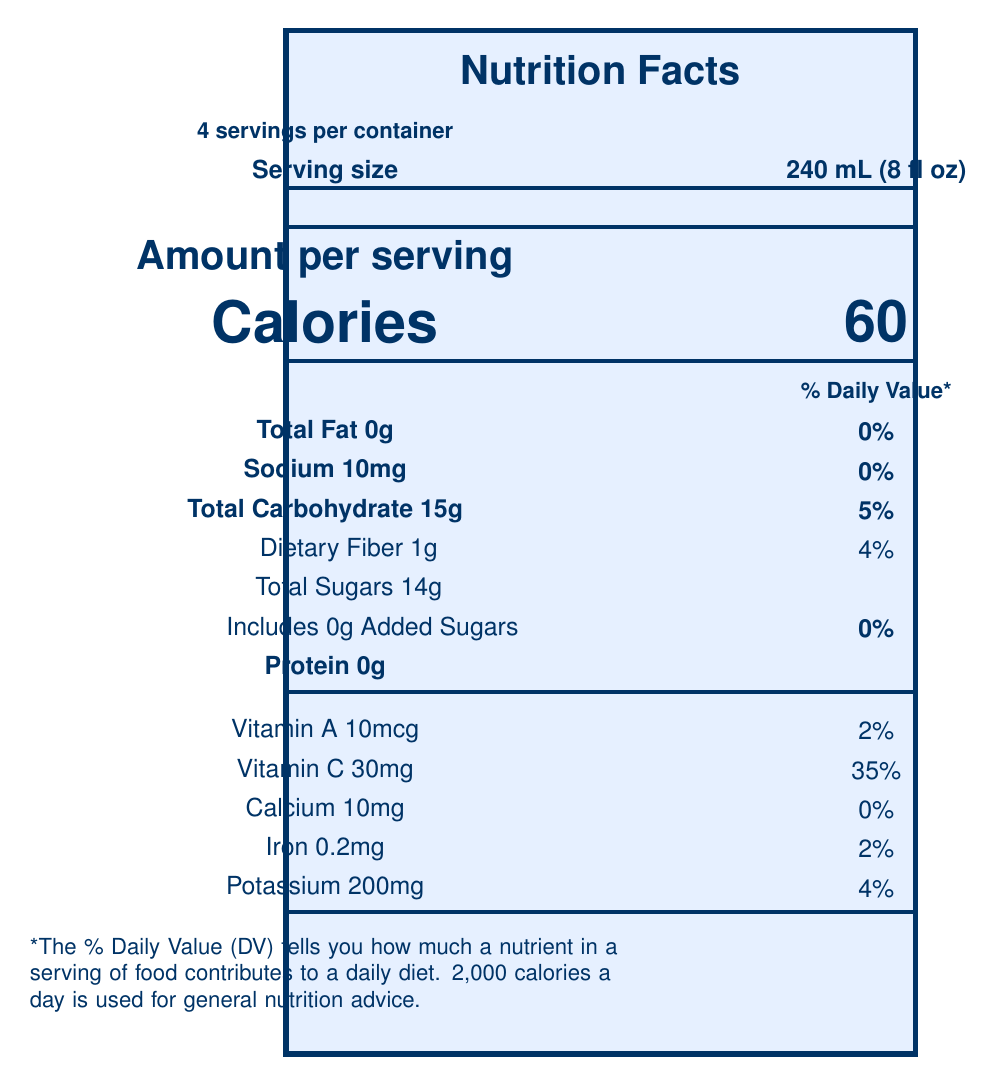what is the serving size of the Naturally Sweet Fruit Fusion? The serving size is clearly stated as "240 mL (8 fl oz)" in the document.
Answer: 240 mL (8 fl oz) how many servings are in one container? The document specifies that there are 4 servings per container.
Answer: 4 how many calories are in one serving? The document lists the calories per serving as 60.
Answer: 60 what is the total amount of sugars in one serving? The document states that the total amount of sugars in one serving is 14g.
Answer: 14g are there any added sugars in this product? The document shows that the amount of added sugars is 0g, implying that there are no added sugars.
Answer: No which company manufactures the Naturally Sweet Fruit Fusion? The manufacturer is explicitly listed as "Healthy Horizons Beverage Co." on the document.
Answer: Healthy Horizons Beverage Co. what are the main ingredients in the Naturally Sweet Fruit Fusion? The list of ingredients includes Apple juice, Pear juice, Grape juice, Natural fruit flavors, Citric acid, and Ascorbic acid (Vitamin C).
Answer: Apple juice, Pear juice, Grape juice, Natural fruit flavors, Citric acid, Ascorbic acid (Vitamin C) what percentage of the daily value of Vitamin C does one serving provide? The document shows that one serving provides 35% of the daily value of Vitamin C.
Answer: 35% what is the amount of dietary fiber per serving? The amount of dietary fiber per serving is listed as 1g in the document.
Answer: 1g why is “Naturally Sweet Fruit Fusion” marketed as having no added sugars? A. It’s 100% fruit juice B. It contains sugar substitutes C. It does not contain any sweeteners The document states that the product has no added sugars and is labeled as "100% fruit juice."
Answer: A what certifications does this product have? A. Fair Trade Certified B. Non-GMO Project Verified C. USDA Organic D. Both B and C The document shows the Non-GMO Project Verified and USDA Organic logos, so the correct answer is both B and C.
Answer: D is Naturally Sweet Fruit Fusion an excellent source of Vitamin C? The health claim section of the document states "Excellent source of Vitamin C."
Answer: Yes how should this product be stored? The storage instructions specify to refrigerate after opening and consume within 7 days.
Answer: Refrigerate after opening and consume within 7 days does this product contain any allergens? The allergen information notes that it is processed in a facility that also processes tree nuts.
Answer: Processed in a facility that also processes tree nuts summarize the main nutrition facts and health claims for the Naturally Sweet Fruit Fusion. The summary should include a description of the nutritional information such as calorie count, major nutrients, and health claims made by the product.
Answer: Naturally Sweet Fruit Fusion is a 100% fruit juice product with 60 calories per serving, no fat, 15g of carbohydrates, 1g of dietary fiber, 14g of natural sugars, and no added sugars. It contains Vitamin A (2% DV), Vitamin C (35% DV), Calcium (0% DV), Iron (2% DV), and Potassium (4% DV). Health claims include no added sugars, excellent source of Vitamin C, low sodium, and it has certifications such as Non-GMO Project Verified and USDA Organic. is there any information provided about the product's environmental impact? The additional information section mentions that the packaging is made from 30% post-consumer recycled materials, indicating an environmental consideration.
Answer: Yes what is the sodium content per serving? The sodium content per serving is listed as 10mg on the document.
Answer: 10mg how many apples are used to make one serving of Naturally Sweet Fruit Fusion? The additional information states that the product is made with the juice of 3 apples, 2 pears, and 10 grapes per 8 fl oz serving.
Answer: 3 apples what are the daily values based on? The footnote informs that the % Daily Value is based on a 2000-calorie daily diet.
Answer: 2000 calories per day how many calories would you consume if you drank the whole container? Since there are 4 servings per container at 60 calories each, consuming the whole container would result in 4 * 60 = 240 calories.
Answer: 240 calories what is the fruit content per 8 fl oz serving? The additional information specifies that each 8 fl oz serving is made with the juice of 3 apples, 2 pears, and 10 grapes.
Answer: Made with the juice of 3 apples, 2 pears, and 10 grapes where can more information about the product be found? The website www.healthyhorizonsbeverages.org is mentioned for more information about the product.
Answer: www.healthyhorizonsbeverages.org where is the facility that processes the juice located? The document does not provide the location of the processing facility, so the information cannot be determined.
Answer: Not enough information 